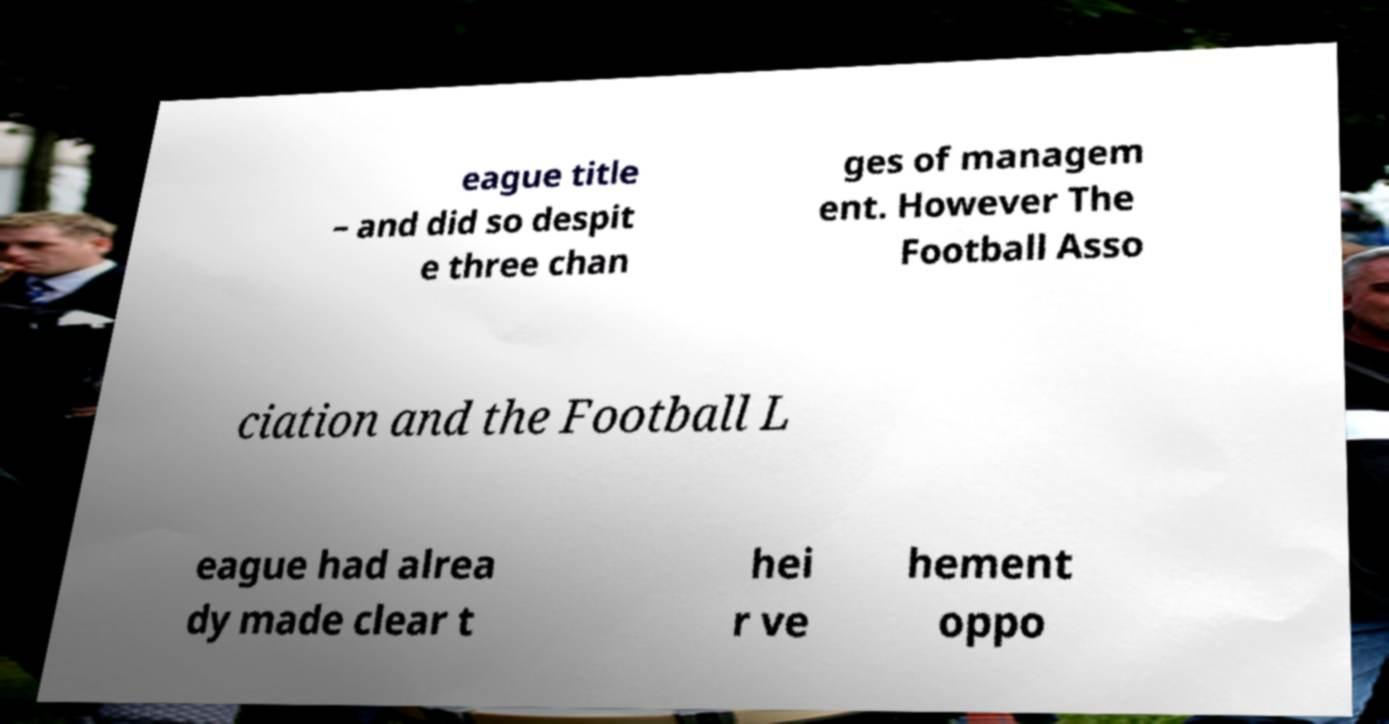Can you read and provide the text displayed in the image?This photo seems to have some interesting text. Can you extract and type it out for me? eague title – and did so despit e three chan ges of managem ent. However The Football Asso ciation and the Football L eague had alrea dy made clear t hei r ve hement oppo 